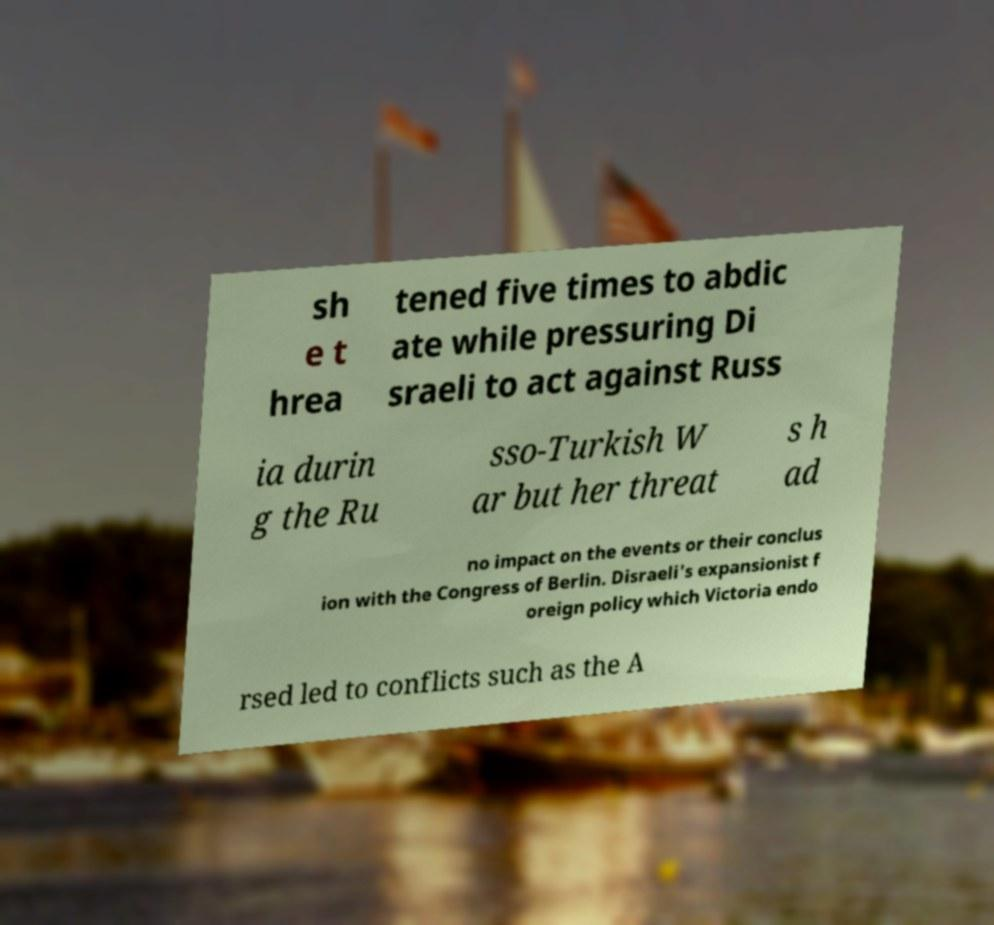For documentation purposes, I need the text within this image transcribed. Could you provide that? sh e t hrea tened five times to abdic ate while pressuring Di sraeli to act against Russ ia durin g the Ru sso-Turkish W ar but her threat s h ad no impact on the events or their conclus ion with the Congress of Berlin. Disraeli's expansionist f oreign policy which Victoria endo rsed led to conflicts such as the A 